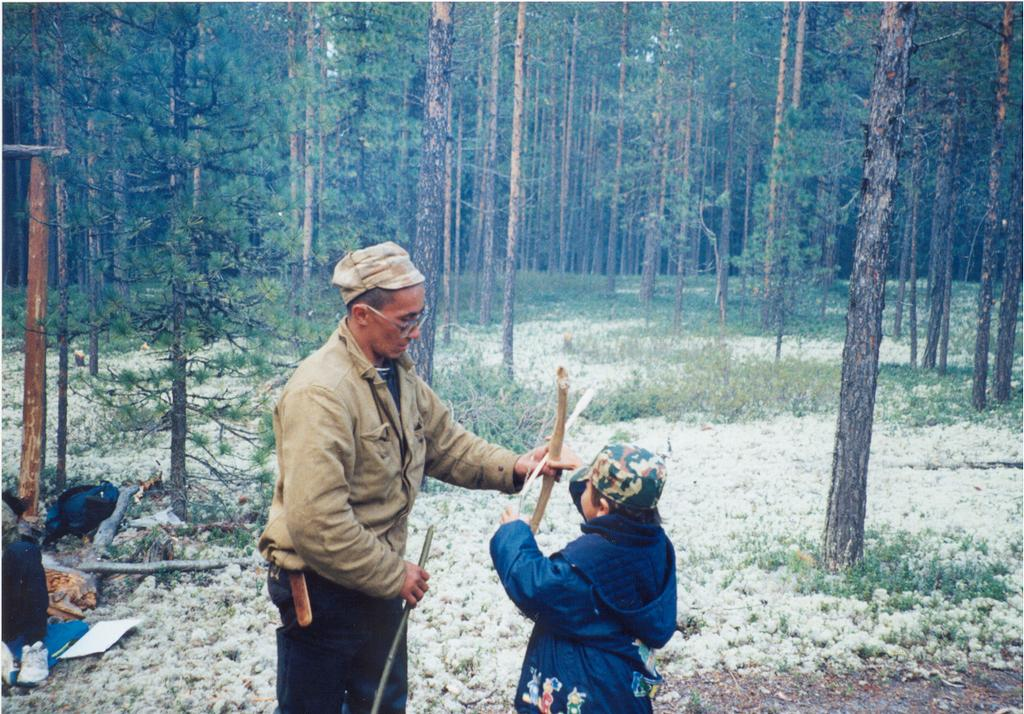Who is present in the image? There is a man and a boy in the image. What are the man and the boy doing? They are standing and holding wooden sticks. What is the condition of the ground in the image? There is snow on the floor. What can be seen in the background of the image? There are trees in the background of the image. What type of bag is the man carrying in the image? There is no bag present in the image. What is the source of the shock experienced by the boy in the image? There is no shock or any indication of an electrical source in the image. 